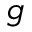Convert formula to latex. <formula><loc_0><loc_0><loc_500><loc_500>g</formula> 